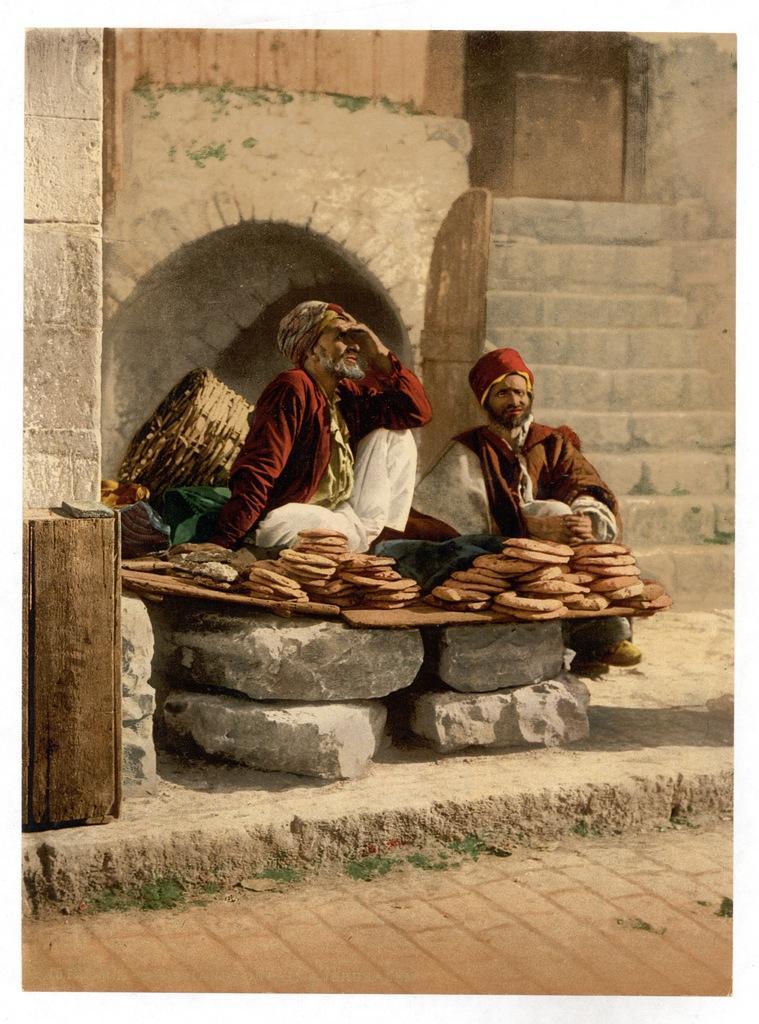Could you give a brief overview of what you see in this image? In this image we can see two persons wearing caps. They are sitting. There is a basket. In front of them there are food items. There are stones. In the back there are steps. Also there is an arch. On the left side there is a wooden object. 